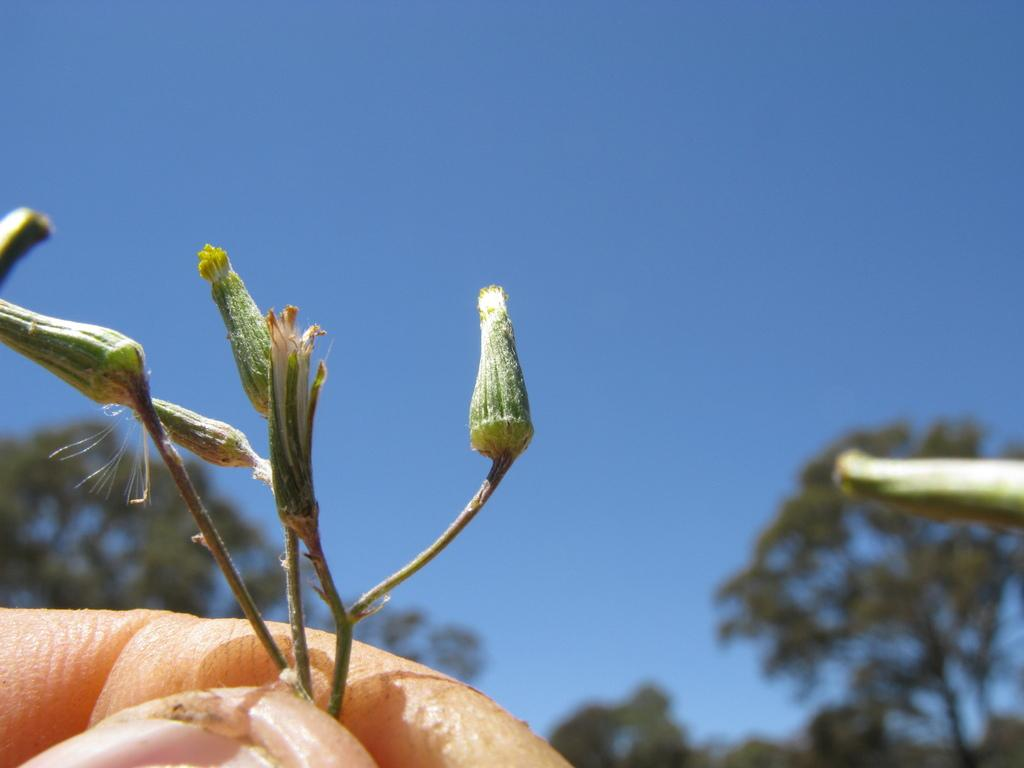What is the main subject of the image? There is a person in the image. What is the person holding in the image? The person is holding buds of a plant. Can you describe the background of the buds? The background of the buds is blurred. What type of letter is being written in the image? There is no letter present in the image; the person is holding buds of a plant. How does the person's breath affect the image? There is no indication of the person's breath in the image, as it only shows the person holding plant buds. 